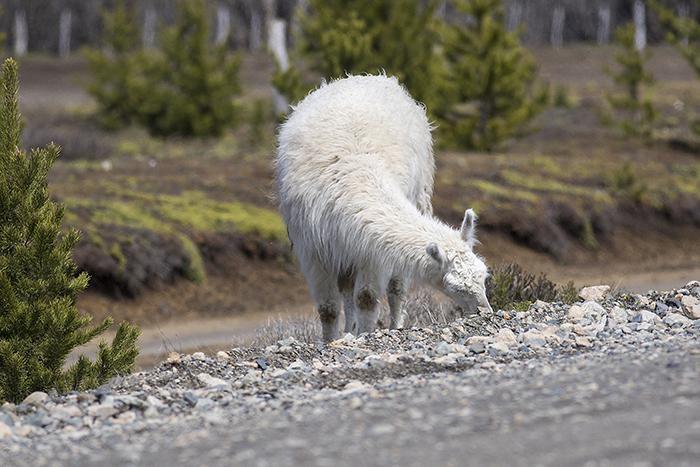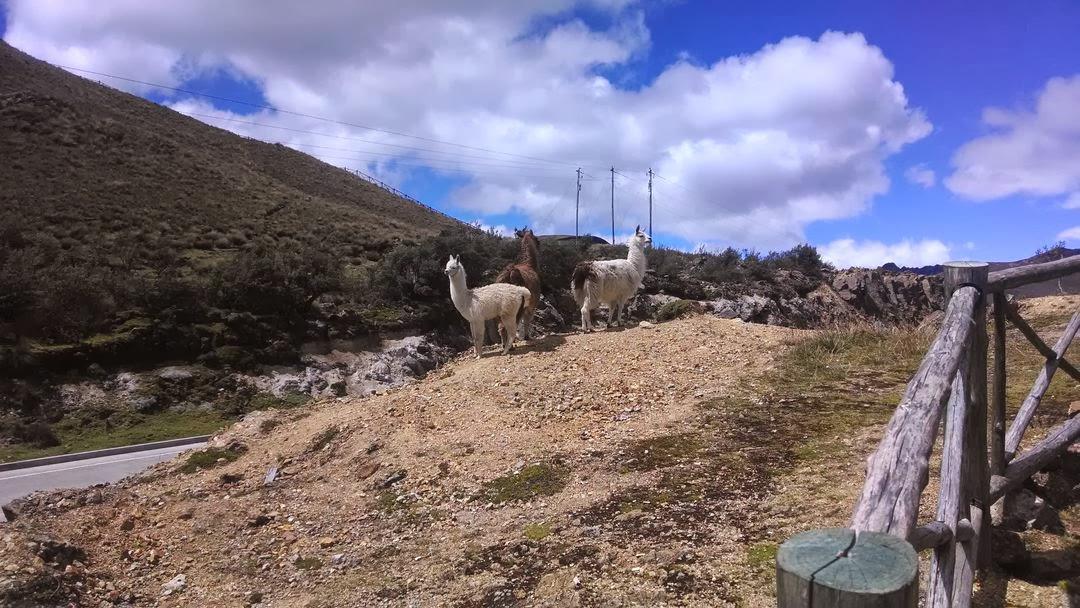The first image is the image on the left, the second image is the image on the right. For the images shown, is this caption "The left image contains exactly three shaggy llamas standing in front of a brown hill, with at least one llama looking directly at the camera." true? Answer yes or no. No. The first image is the image on the left, the second image is the image on the right. Given the left and right images, does the statement "There are three llamas in the left image." hold true? Answer yes or no. No. 